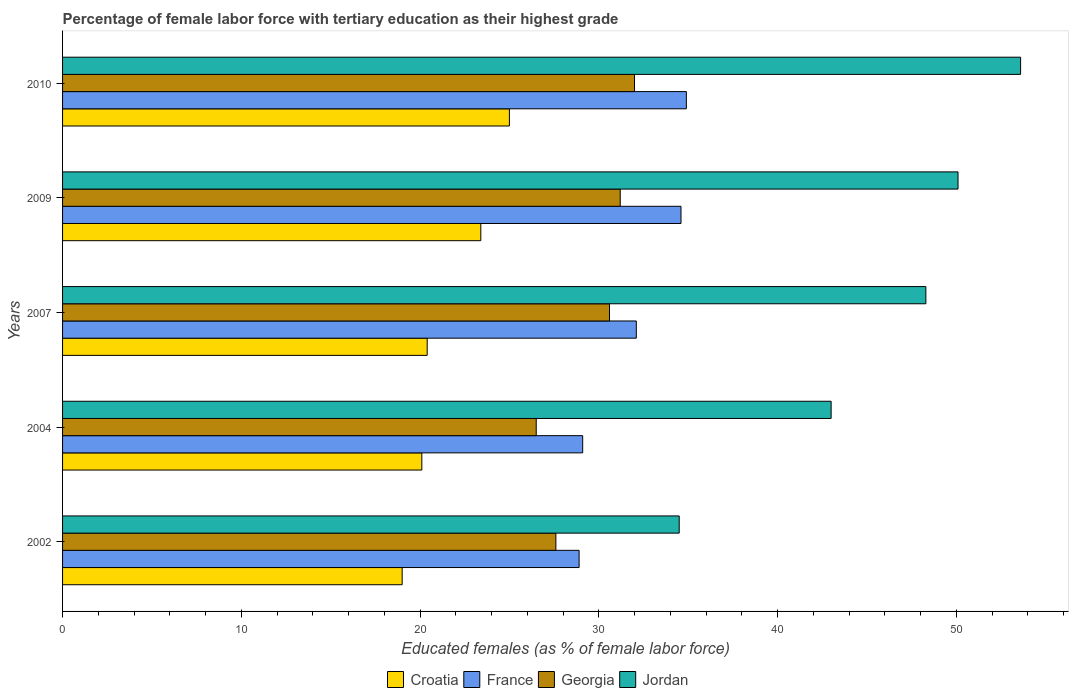Are the number of bars per tick equal to the number of legend labels?
Keep it short and to the point. Yes. Are the number of bars on each tick of the Y-axis equal?
Provide a succinct answer. Yes. How many bars are there on the 1st tick from the top?
Give a very brief answer. 4. What is the label of the 1st group of bars from the top?
Your answer should be compact. 2010. What is the percentage of female labor force with tertiary education in Jordan in 2002?
Make the answer very short. 34.5. Across all years, what is the minimum percentage of female labor force with tertiary education in Croatia?
Provide a succinct answer. 19. What is the total percentage of female labor force with tertiary education in Georgia in the graph?
Your answer should be compact. 147.9. What is the difference between the percentage of female labor force with tertiary education in Georgia in 2004 and that in 2009?
Ensure brevity in your answer.  -4.7. What is the difference between the percentage of female labor force with tertiary education in Croatia in 2010 and the percentage of female labor force with tertiary education in Jordan in 2009?
Your answer should be compact. -25.1. What is the average percentage of female labor force with tertiary education in Georgia per year?
Offer a terse response. 29.58. In the year 2004, what is the difference between the percentage of female labor force with tertiary education in Georgia and percentage of female labor force with tertiary education in Jordan?
Offer a very short reply. -16.5. In how many years, is the percentage of female labor force with tertiary education in Croatia greater than 30 %?
Offer a terse response. 0. What is the ratio of the percentage of female labor force with tertiary education in Jordan in 2007 to that in 2010?
Ensure brevity in your answer.  0.9. Is the difference between the percentage of female labor force with tertiary education in Georgia in 2002 and 2007 greater than the difference between the percentage of female labor force with tertiary education in Jordan in 2002 and 2007?
Make the answer very short. Yes. What is the difference between the highest and the second highest percentage of female labor force with tertiary education in Croatia?
Make the answer very short. 1.6. What is the difference between the highest and the lowest percentage of female labor force with tertiary education in Georgia?
Provide a succinct answer. 5.5. In how many years, is the percentage of female labor force with tertiary education in Jordan greater than the average percentage of female labor force with tertiary education in Jordan taken over all years?
Offer a terse response. 3. Is the sum of the percentage of female labor force with tertiary education in France in 2002 and 2004 greater than the maximum percentage of female labor force with tertiary education in Croatia across all years?
Your answer should be compact. Yes. Is it the case that in every year, the sum of the percentage of female labor force with tertiary education in Croatia and percentage of female labor force with tertiary education in France is greater than the sum of percentage of female labor force with tertiary education in Georgia and percentage of female labor force with tertiary education in Jordan?
Provide a succinct answer. No. What does the 2nd bar from the top in 2010 represents?
Provide a short and direct response. Georgia. What does the 1st bar from the bottom in 2002 represents?
Make the answer very short. Croatia. Does the graph contain grids?
Make the answer very short. No. Where does the legend appear in the graph?
Your response must be concise. Bottom center. How many legend labels are there?
Offer a very short reply. 4. What is the title of the graph?
Provide a short and direct response. Percentage of female labor force with tertiary education as their highest grade. What is the label or title of the X-axis?
Offer a terse response. Educated females (as % of female labor force). What is the label or title of the Y-axis?
Your answer should be compact. Years. What is the Educated females (as % of female labor force) in France in 2002?
Provide a short and direct response. 28.9. What is the Educated females (as % of female labor force) in Georgia in 2002?
Your answer should be compact. 27.6. What is the Educated females (as % of female labor force) of Jordan in 2002?
Offer a very short reply. 34.5. What is the Educated females (as % of female labor force) of Croatia in 2004?
Offer a very short reply. 20.1. What is the Educated females (as % of female labor force) in France in 2004?
Provide a short and direct response. 29.1. What is the Educated females (as % of female labor force) of Croatia in 2007?
Offer a terse response. 20.4. What is the Educated females (as % of female labor force) in France in 2007?
Your answer should be very brief. 32.1. What is the Educated females (as % of female labor force) of Georgia in 2007?
Provide a short and direct response. 30.6. What is the Educated females (as % of female labor force) of Jordan in 2007?
Offer a terse response. 48.3. What is the Educated females (as % of female labor force) of Croatia in 2009?
Your answer should be very brief. 23.4. What is the Educated females (as % of female labor force) in France in 2009?
Give a very brief answer. 34.6. What is the Educated females (as % of female labor force) in Georgia in 2009?
Give a very brief answer. 31.2. What is the Educated females (as % of female labor force) in Jordan in 2009?
Your answer should be very brief. 50.1. What is the Educated females (as % of female labor force) in France in 2010?
Your answer should be very brief. 34.9. What is the Educated females (as % of female labor force) in Georgia in 2010?
Ensure brevity in your answer.  32. What is the Educated females (as % of female labor force) of Jordan in 2010?
Your answer should be very brief. 53.6. Across all years, what is the maximum Educated females (as % of female labor force) of France?
Your answer should be very brief. 34.9. Across all years, what is the maximum Educated females (as % of female labor force) in Jordan?
Offer a very short reply. 53.6. Across all years, what is the minimum Educated females (as % of female labor force) of Croatia?
Your answer should be compact. 19. Across all years, what is the minimum Educated females (as % of female labor force) in France?
Provide a succinct answer. 28.9. Across all years, what is the minimum Educated females (as % of female labor force) of Jordan?
Provide a short and direct response. 34.5. What is the total Educated females (as % of female labor force) of Croatia in the graph?
Offer a very short reply. 107.9. What is the total Educated females (as % of female labor force) of France in the graph?
Make the answer very short. 159.6. What is the total Educated females (as % of female labor force) in Georgia in the graph?
Ensure brevity in your answer.  147.9. What is the total Educated females (as % of female labor force) in Jordan in the graph?
Provide a short and direct response. 229.5. What is the difference between the Educated females (as % of female labor force) in Croatia in 2002 and that in 2004?
Provide a short and direct response. -1.1. What is the difference between the Educated females (as % of female labor force) of Georgia in 2002 and that in 2004?
Your answer should be very brief. 1.1. What is the difference between the Educated females (as % of female labor force) of Jordan in 2002 and that in 2004?
Offer a terse response. -8.5. What is the difference between the Educated females (as % of female labor force) of Georgia in 2002 and that in 2007?
Your response must be concise. -3. What is the difference between the Educated females (as % of female labor force) of Jordan in 2002 and that in 2007?
Your response must be concise. -13.8. What is the difference between the Educated females (as % of female labor force) in Croatia in 2002 and that in 2009?
Your answer should be very brief. -4.4. What is the difference between the Educated females (as % of female labor force) in France in 2002 and that in 2009?
Offer a very short reply. -5.7. What is the difference between the Educated females (as % of female labor force) in Jordan in 2002 and that in 2009?
Provide a short and direct response. -15.6. What is the difference between the Educated females (as % of female labor force) in France in 2002 and that in 2010?
Your answer should be compact. -6. What is the difference between the Educated females (as % of female labor force) in Jordan in 2002 and that in 2010?
Make the answer very short. -19.1. What is the difference between the Educated females (as % of female labor force) of France in 2004 and that in 2007?
Give a very brief answer. -3. What is the difference between the Educated females (as % of female labor force) of France in 2004 and that in 2009?
Keep it short and to the point. -5.5. What is the difference between the Educated females (as % of female labor force) of Georgia in 2004 and that in 2009?
Offer a very short reply. -4.7. What is the difference between the Educated females (as % of female labor force) in France in 2004 and that in 2010?
Ensure brevity in your answer.  -5.8. What is the difference between the Educated females (as % of female labor force) of Jordan in 2004 and that in 2010?
Keep it short and to the point. -10.6. What is the difference between the Educated females (as % of female labor force) in Croatia in 2007 and that in 2010?
Your answer should be compact. -4.6. What is the difference between the Educated females (as % of female labor force) in Jordan in 2007 and that in 2010?
Give a very brief answer. -5.3. What is the difference between the Educated females (as % of female labor force) of Croatia in 2009 and that in 2010?
Offer a terse response. -1.6. What is the difference between the Educated females (as % of female labor force) of France in 2009 and that in 2010?
Keep it short and to the point. -0.3. What is the difference between the Educated females (as % of female labor force) of Jordan in 2009 and that in 2010?
Provide a short and direct response. -3.5. What is the difference between the Educated females (as % of female labor force) in France in 2002 and the Educated females (as % of female labor force) in Jordan in 2004?
Your answer should be compact. -14.1. What is the difference between the Educated females (as % of female labor force) of Georgia in 2002 and the Educated females (as % of female labor force) of Jordan in 2004?
Your response must be concise. -15.4. What is the difference between the Educated females (as % of female labor force) of Croatia in 2002 and the Educated females (as % of female labor force) of France in 2007?
Keep it short and to the point. -13.1. What is the difference between the Educated females (as % of female labor force) of Croatia in 2002 and the Educated females (as % of female labor force) of Jordan in 2007?
Provide a succinct answer. -29.3. What is the difference between the Educated females (as % of female labor force) in France in 2002 and the Educated females (as % of female labor force) in Jordan in 2007?
Keep it short and to the point. -19.4. What is the difference between the Educated females (as % of female labor force) of Georgia in 2002 and the Educated females (as % of female labor force) of Jordan in 2007?
Your response must be concise. -20.7. What is the difference between the Educated females (as % of female labor force) of Croatia in 2002 and the Educated females (as % of female labor force) of France in 2009?
Your response must be concise. -15.6. What is the difference between the Educated females (as % of female labor force) of Croatia in 2002 and the Educated females (as % of female labor force) of Jordan in 2009?
Provide a short and direct response. -31.1. What is the difference between the Educated females (as % of female labor force) of France in 2002 and the Educated females (as % of female labor force) of Georgia in 2009?
Ensure brevity in your answer.  -2.3. What is the difference between the Educated females (as % of female labor force) in France in 2002 and the Educated females (as % of female labor force) in Jordan in 2009?
Keep it short and to the point. -21.2. What is the difference between the Educated females (as % of female labor force) of Georgia in 2002 and the Educated females (as % of female labor force) of Jordan in 2009?
Keep it short and to the point. -22.5. What is the difference between the Educated females (as % of female labor force) in Croatia in 2002 and the Educated females (as % of female labor force) in France in 2010?
Give a very brief answer. -15.9. What is the difference between the Educated females (as % of female labor force) of Croatia in 2002 and the Educated females (as % of female labor force) of Georgia in 2010?
Your answer should be compact. -13. What is the difference between the Educated females (as % of female labor force) of Croatia in 2002 and the Educated females (as % of female labor force) of Jordan in 2010?
Ensure brevity in your answer.  -34.6. What is the difference between the Educated females (as % of female labor force) in France in 2002 and the Educated females (as % of female labor force) in Georgia in 2010?
Your response must be concise. -3.1. What is the difference between the Educated females (as % of female labor force) in France in 2002 and the Educated females (as % of female labor force) in Jordan in 2010?
Offer a terse response. -24.7. What is the difference between the Educated females (as % of female labor force) in Georgia in 2002 and the Educated females (as % of female labor force) in Jordan in 2010?
Your response must be concise. -26. What is the difference between the Educated females (as % of female labor force) of Croatia in 2004 and the Educated females (as % of female labor force) of France in 2007?
Make the answer very short. -12. What is the difference between the Educated females (as % of female labor force) of Croatia in 2004 and the Educated females (as % of female labor force) of Georgia in 2007?
Keep it short and to the point. -10.5. What is the difference between the Educated females (as % of female labor force) in Croatia in 2004 and the Educated females (as % of female labor force) in Jordan in 2007?
Make the answer very short. -28.2. What is the difference between the Educated females (as % of female labor force) in France in 2004 and the Educated females (as % of female labor force) in Jordan in 2007?
Your answer should be compact. -19.2. What is the difference between the Educated females (as % of female labor force) in Georgia in 2004 and the Educated females (as % of female labor force) in Jordan in 2007?
Provide a succinct answer. -21.8. What is the difference between the Educated females (as % of female labor force) of Croatia in 2004 and the Educated females (as % of female labor force) of France in 2009?
Offer a terse response. -14.5. What is the difference between the Educated females (as % of female labor force) of Croatia in 2004 and the Educated females (as % of female labor force) of Georgia in 2009?
Give a very brief answer. -11.1. What is the difference between the Educated females (as % of female labor force) in Croatia in 2004 and the Educated females (as % of female labor force) in Jordan in 2009?
Keep it short and to the point. -30. What is the difference between the Educated females (as % of female labor force) in France in 2004 and the Educated females (as % of female labor force) in Jordan in 2009?
Offer a very short reply. -21. What is the difference between the Educated females (as % of female labor force) in Georgia in 2004 and the Educated females (as % of female labor force) in Jordan in 2009?
Your response must be concise. -23.6. What is the difference between the Educated females (as % of female labor force) of Croatia in 2004 and the Educated females (as % of female labor force) of France in 2010?
Offer a very short reply. -14.8. What is the difference between the Educated females (as % of female labor force) in Croatia in 2004 and the Educated females (as % of female labor force) in Jordan in 2010?
Make the answer very short. -33.5. What is the difference between the Educated females (as % of female labor force) of France in 2004 and the Educated females (as % of female labor force) of Jordan in 2010?
Your answer should be compact. -24.5. What is the difference between the Educated females (as % of female labor force) in Georgia in 2004 and the Educated females (as % of female labor force) in Jordan in 2010?
Provide a succinct answer. -27.1. What is the difference between the Educated females (as % of female labor force) in Croatia in 2007 and the Educated females (as % of female labor force) in France in 2009?
Your response must be concise. -14.2. What is the difference between the Educated females (as % of female labor force) in Croatia in 2007 and the Educated females (as % of female labor force) in Jordan in 2009?
Your response must be concise. -29.7. What is the difference between the Educated females (as % of female labor force) of France in 2007 and the Educated females (as % of female labor force) of Georgia in 2009?
Keep it short and to the point. 0.9. What is the difference between the Educated females (as % of female labor force) of Georgia in 2007 and the Educated females (as % of female labor force) of Jordan in 2009?
Offer a terse response. -19.5. What is the difference between the Educated females (as % of female labor force) in Croatia in 2007 and the Educated females (as % of female labor force) in Georgia in 2010?
Provide a short and direct response. -11.6. What is the difference between the Educated females (as % of female labor force) of Croatia in 2007 and the Educated females (as % of female labor force) of Jordan in 2010?
Provide a short and direct response. -33.2. What is the difference between the Educated females (as % of female labor force) in France in 2007 and the Educated females (as % of female labor force) in Jordan in 2010?
Provide a succinct answer. -21.5. What is the difference between the Educated females (as % of female labor force) in Georgia in 2007 and the Educated females (as % of female labor force) in Jordan in 2010?
Provide a short and direct response. -23. What is the difference between the Educated females (as % of female labor force) of Croatia in 2009 and the Educated females (as % of female labor force) of Jordan in 2010?
Make the answer very short. -30.2. What is the difference between the Educated females (as % of female labor force) in France in 2009 and the Educated females (as % of female labor force) in Georgia in 2010?
Offer a very short reply. 2.6. What is the difference between the Educated females (as % of female labor force) in Georgia in 2009 and the Educated females (as % of female labor force) in Jordan in 2010?
Your response must be concise. -22.4. What is the average Educated females (as % of female labor force) of Croatia per year?
Ensure brevity in your answer.  21.58. What is the average Educated females (as % of female labor force) of France per year?
Provide a succinct answer. 31.92. What is the average Educated females (as % of female labor force) in Georgia per year?
Make the answer very short. 29.58. What is the average Educated females (as % of female labor force) of Jordan per year?
Your answer should be very brief. 45.9. In the year 2002, what is the difference between the Educated females (as % of female labor force) in Croatia and Educated females (as % of female labor force) in France?
Your answer should be compact. -9.9. In the year 2002, what is the difference between the Educated females (as % of female labor force) of Croatia and Educated females (as % of female labor force) of Georgia?
Your answer should be very brief. -8.6. In the year 2002, what is the difference between the Educated females (as % of female labor force) of Croatia and Educated females (as % of female labor force) of Jordan?
Give a very brief answer. -15.5. In the year 2002, what is the difference between the Educated females (as % of female labor force) in France and Educated females (as % of female labor force) in Georgia?
Provide a succinct answer. 1.3. In the year 2002, what is the difference between the Educated females (as % of female labor force) in Georgia and Educated females (as % of female labor force) in Jordan?
Your response must be concise. -6.9. In the year 2004, what is the difference between the Educated females (as % of female labor force) of Croatia and Educated females (as % of female labor force) of Georgia?
Your answer should be compact. -6.4. In the year 2004, what is the difference between the Educated females (as % of female labor force) in Croatia and Educated females (as % of female labor force) in Jordan?
Offer a very short reply. -22.9. In the year 2004, what is the difference between the Educated females (as % of female labor force) of France and Educated females (as % of female labor force) of Georgia?
Your response must be concise. 2.6. In the year 2004, what is the difference between the Educated females (as % of female labor force) of France and Educated females (as % of female labor force) of Jordan?
Ensure brevity in your answer.  -13.9. In the year 2004, what is the difference between the Educated females (as % of female labor force) in Georgia and Educated females (as % of female labor force) in Jordan?
Give a very brief answer. -16.5. In the year 2007, what is the difference between the Educated females (as % of female labor force) in Croatia and Educated females (as % of female labor force) in Jordan?
Your answer should be compact. -27.9. In the year 2007, what is the difference between the Educated females (as % of female labor force) of France and Educated females (as % of female labor force) of Jordan?
Keep it short and to the point. -16.2. In the year 2007, what is the difference between the Educated females (as % of female labor force) in Georgia and Educated females (as % of female labor force) in Jordan?
Give a very brief answer. -17.7. In the year 2009, what is the difference between the Educated females (as % of female labor force) of Croatia and Educated females (as % of female labor force) of Jordan?
Keep it short and to the point. -26.7. In the year 2009, what is the difference between the Educated females (as % of female labor force) of France and Educated females (as % of female labor force) of Georgia?
Your answer should be very brief. 3.4. In the year 2009, what is the difference between the Educated females (as % of female labor force) in France and Educated females (as % of female labor force) in Jordan?
Make the answer very short. -15.5. In the year 2009, what is the difference between the Educated females (as % of female labor force) in Georgia and Educated females (as % of female labor force) in Jordan?
Keep it short and to the point. -18.9. In the year 2010, what is the difference between the Educated females (as % of female labor force) in Croatia and Educated females (as % of female labor force) in Georgia?
Ensure brevity in your answer.  -7. In the year 2010, what is the difference between the Educated females (as % of female labor force) in Croatia and Educated females (as % of female labor force) in Jordan?
Keep it short and to the point. -28.6. In the year 2010, what is the difference between the Educated females (as % of female labor force) of France and Educated females (as % of female labor force) of Jordan?
Give a very brief answer. -18.7. In the year 2010, what is the difference between the Educated females (as % of female labor force) in Georgia and Educated females (as % of female labor force) in Jordan?
Your answer should be very brief. -21.6. What is the ratio of the Educated females (as % of female labor force) in Croatia in 2002 to that in 2004?
Your answer should be compact. 0.95. What is the ratio of the Educated females (as % of female labor force) in Georgia in 2002 to that in 2004?
Provide a succinct answer. 1.04. What is the ratio of the Educated females (as % of female labor force) of Jordan in 2002 to that in 2004?
Provide a succinct answer. 0.8. What is the ratio of the Educated females (as % of female labor force) in Croatia in 2002 to that in 2007?
Provide a short and direct response. 0.93. What is the ratio of the Educated females (as % of female labor force) in France in 2002 to that in 2007?
Provide a succinct answer. 0.9. What is the ratio of the Educated females (as % of female labor force) of Georgia in 2002 to that in 2007?
Your response must be concise. 0.9. What is the ratio of the Educated females (as % of female labor force) in Jordan in 2002 to that in 2007?
Ensure brevity in your answer.  0.71. What is the ratio of the Educated females (as % of female labor force) in Croatia in 2002 to that in 2009?
Provide a short and direct response. 0.81. What is the ratio of the Educated females (as % of female labor force) of France in 2002 to that in 2009?
Your answer should be compact. 0.84. What is the ratio of the Educated females (as % of female labor force) of Georgia in 2002 to that in 2009?
Make the answer very short. 0.88. What is the ratio of the Educated females (as % of female labor force) of Jordan in 2002 to that in 2009?
Provide a succinct answer. 0.69. What is the ratio of the Educated females (as % of female labor force) of Croatia in 2002 to that in 2010?
Ensure brevity in your answer.  0.76. What is the ratio of the Educated females (as % of female labor force) of France in 2002 to that in 2010?
Make the answer very short. 0.83. What is the ratio of the Educated females (as % of female labor force) of Georgia in 2002 to that in 2010?
Your answer should be compact. 0.86. What is the ratio of the Educated females (as % of female labor force) in Jordan in 2002 to that in 2010?
Ensure brevity in your answer.  0.64. What is the ratio of the Educated females (as % of female labor force) of France in 2004 to that in 2007?
Ensure brevity in your answer.  0.91. What is the ratio of the Educated females (as % of female labor force) of Georgia in 2004 to that in 2007?
Give a very brief answer. 0.87. What is the ratio of the Educated females (as % of female labor force) in Jordan in 2004 to that in 2007?
Your answer should be compact. 0.89. What is the ratio of the Educated females (as % of female labor force) in Croatia in 2004 to that in 2009?
Your answer should be very brief. 0.86. What is the ratio of the Educated females (as % of female labor force) of France in 2004 to that in 2009?
Give a very brief answer. 0.84. What is the ratio of the Educated females (as % of female labor force) in Georgia in 2004 to that in 2009?
Give a very brief answer. 0.85. What is the ratio of the Educated females (as % of female labor force) of Jordan in 2004 to that in 2009?
Your answer should be very brief. 0.86. What is the ratio of the Educated females (as % of female labor force) of Croatia in 2004 to that in 2010?
Your answer should be compact. 0.8. What is the ratio of the Educated females (as % of female labor force) of France in 2004 to that in 2010?
Provide a succinct answer. 0.83. What is the ratio of the Educated females (as % of female labor force) of Georgia in 2004 to that in 2010?
Provide a short and direct response. 0.83. What is the ratio of the Educated females (as % of female labor force) of Jordan in 2004 to that in 2010?
Make the answer very short. 0.8. What is the ratio of the Educated females (as % of female labor force) of Croatia in 2007 to that in 2009?
Your answer should be compact. 0.87. What is the ratio of the Educated females (as % of female labor force) of France in 2007 to that in 2009?
Keep it short and to the point. 0.93. What is the ratio of the Educated females (as % of female labor force) in Georgia in 2007 to that in 2009?
Offer a very short reply. 0.98. What is the ratio of the Educated females (as % of female labor force) of Jordan in 2007 to that in 2009?
Offer a terse response. 0.96. What is the ratio of the Educated females (as % of female labor force) in Croatia in 2007 to that in 2010?
Provide a succinct answer. 0.82. What is the ratio of the Educated females (as % of female labor force) in France in 2007 to that in 2010?
Offer a terse response. 0.92. What is the ratio of the Educated females (as % of female labor force) of Georgia in 2007 to that in 2010?
Your response must be concise. 0.96. What is the ratio of the Educated females (as % of female labor force) of Jordan in 2007 to that in 2010?
Make the answer very short. 0.9. What is the ratio of the Educated females (as % of female labor force) in Croatia in 2009 to that in 2010?
Provide a succinct answer. 0.94. What is the ratio of the Educated females (as % of female labor force) in France in 2009 to that in 2010?
Ensure brevity in your answer.  0.99. What is the ratio of the Educated females (as % of female labor force) in Georgia in 2009 to that in 2010?
Your answer should be very brief. 0.97. What is the ratio of the Educated females (as % of female labor force) in Jordan in 2009 to that in 2010?
Keep it short and to the point. 0.93. What is the difference between the highest and the second highest Educated females (as % of female labor force) in Croatia?
Your answer should be very brief. 1.6. What is the difference between the highest and the lowest Educated females (as % of female labor force) in France?
Offer a very short reply. 6. What is the difference between the highest and the lowest Educated females (as % of female labor force) in Jordan?
Make the answer very short. 19.1. 